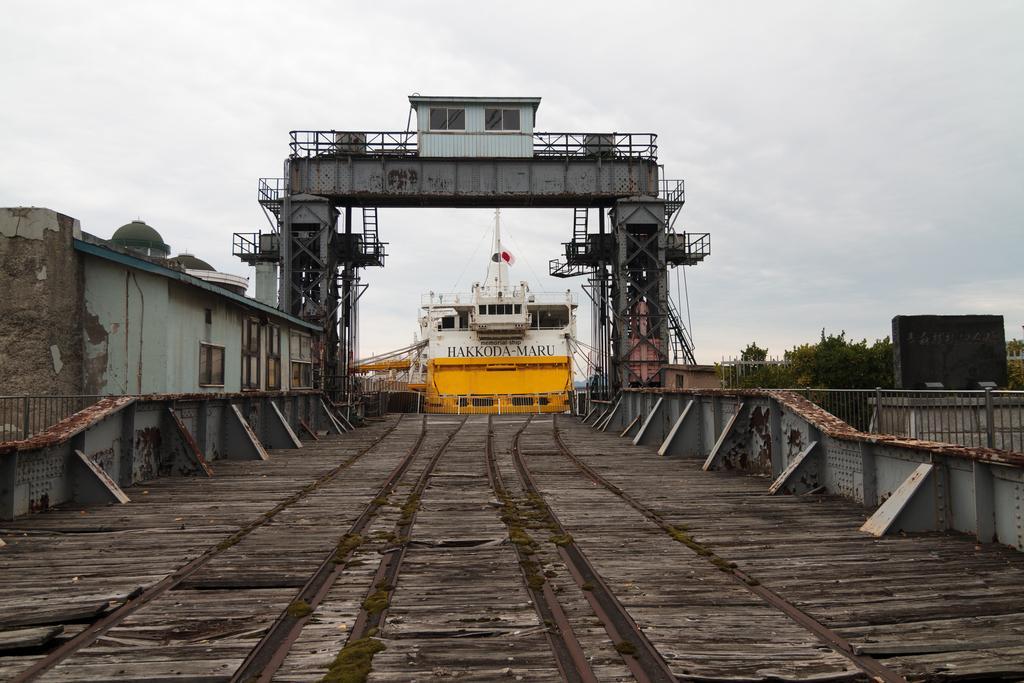Can you describe this image briefly? In this picture I can see there is a railway track, there is a building on the left side and there are trees on the right side, there is a yellow and white color ship, there is an iron arch and in the backdrop and the sky is clear. 